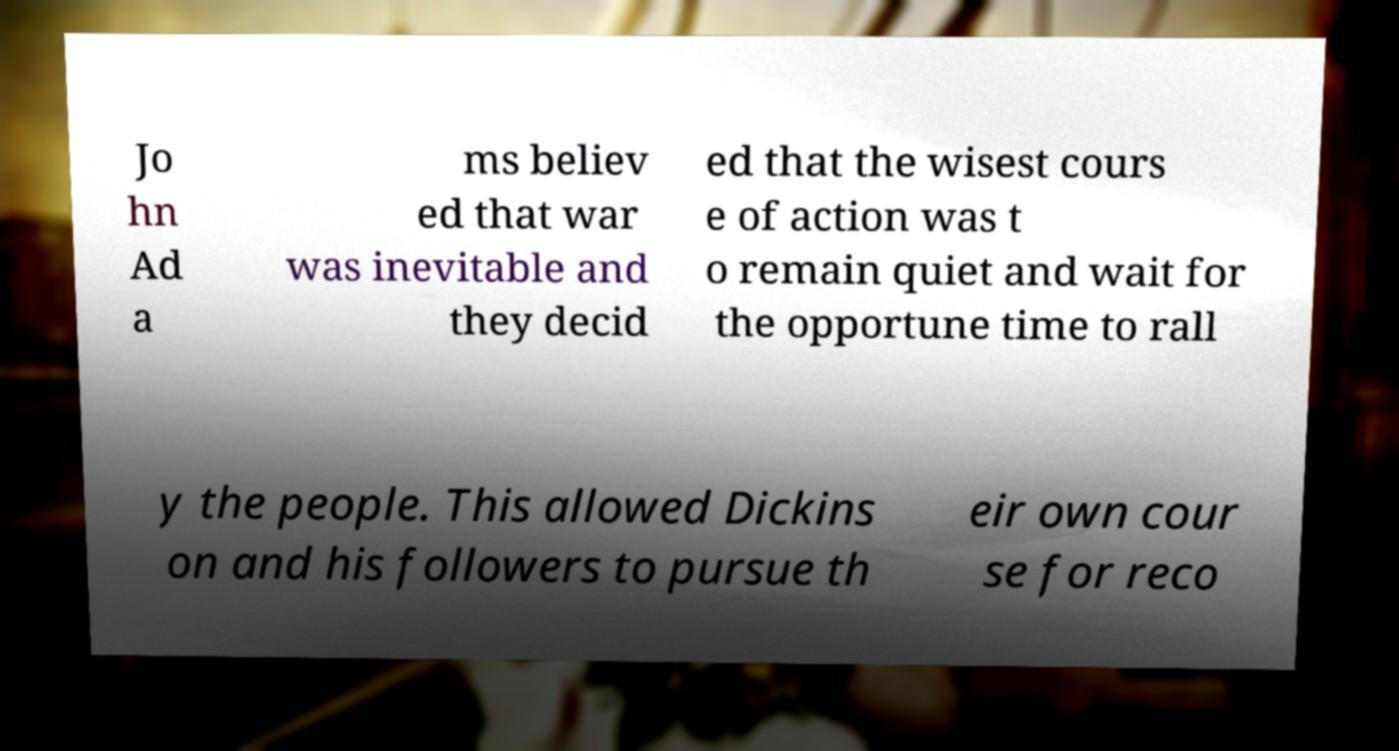I need the written content from this picture converted into text. Can you do that? Jo hn Ad a ms believ ed that war was inevitable and they decid ed that the wisest cours e of action was t o remain quiet and wait for the opportune time to rall y the people. This allowed Dickins on and his followers to pursue th eir own cour se for reco 